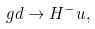Convert formula to latex. <formula><loc_0><loc_0><loc_500><loc_500>g d \rightarrow H ^ { - } u ,</formula> 